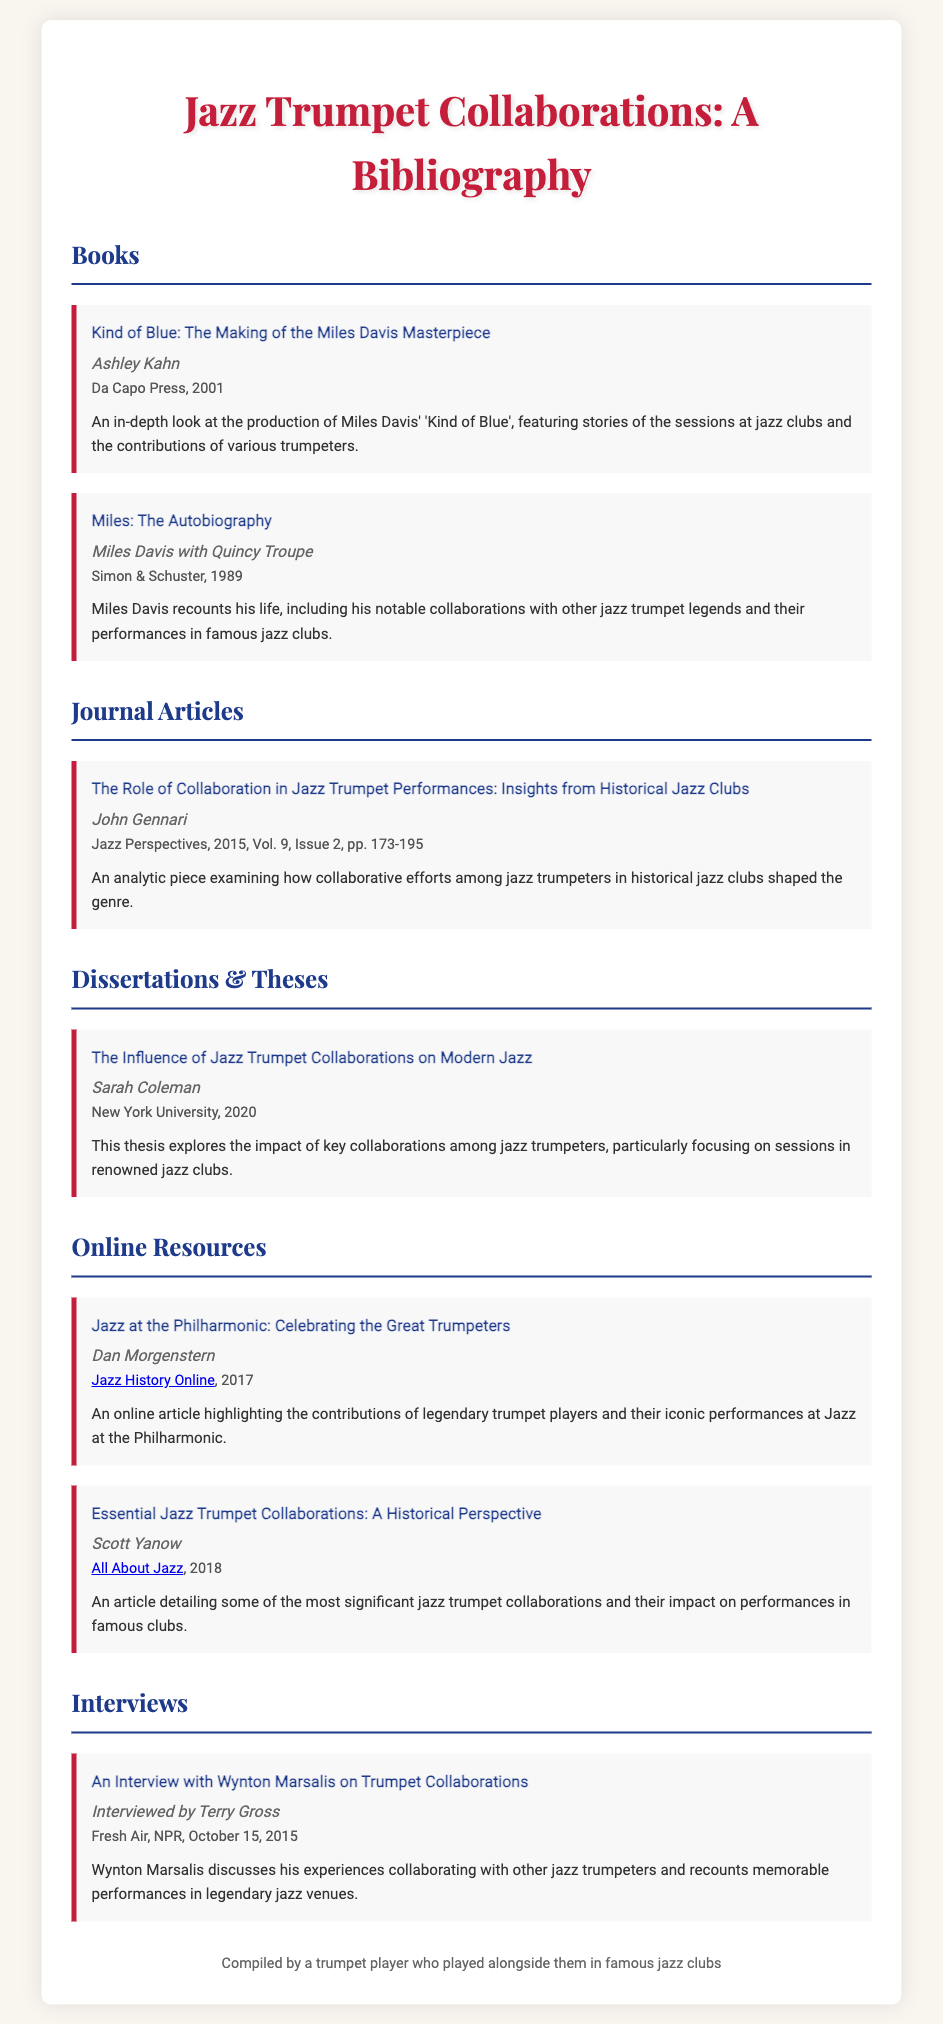what is the title of the first book listed? The title of the first book listed is provided in the document under the "Books" section.
Answer: Kind of Blue: The Making of the Miles Davis Masterpiece who is the author of the article examining collaboration in jazz trumpet performances? The author of the article can be found in the "Journal Articles" section of the document.
Answer: John Gennari what year was the dissertation by Sarah Coleman published? The year of publication for the dissertation is given in the "Dissertations & Theses" section.
Answer: 2020 how many online resources are listed in the bibliography? The total number of online resources can be counted in the "Online Resources" section.
Answer: 2 which famous venue is mentioned in the interview with Wynton Marsalis? The venue referred to in the interview is found in the summary of the related entry in the document.
Answer: legendary jazz venues what is a key theme discussed in the article by Scott Yanow? The theme is detailed in the entry summary under "Online Resources".
Answer: significant jazz trumpet collaborations who published "Miles: The Autobiography"? The publisher's name can be found in the entry details for the book under the "Books" section.
Answer: Simon & Schuster what type of document is "The Role of Collaboration in Jazz Trumpet Performances"? The type of document is specified in the header of the respective section it falls under.
Answer: Journal Article 